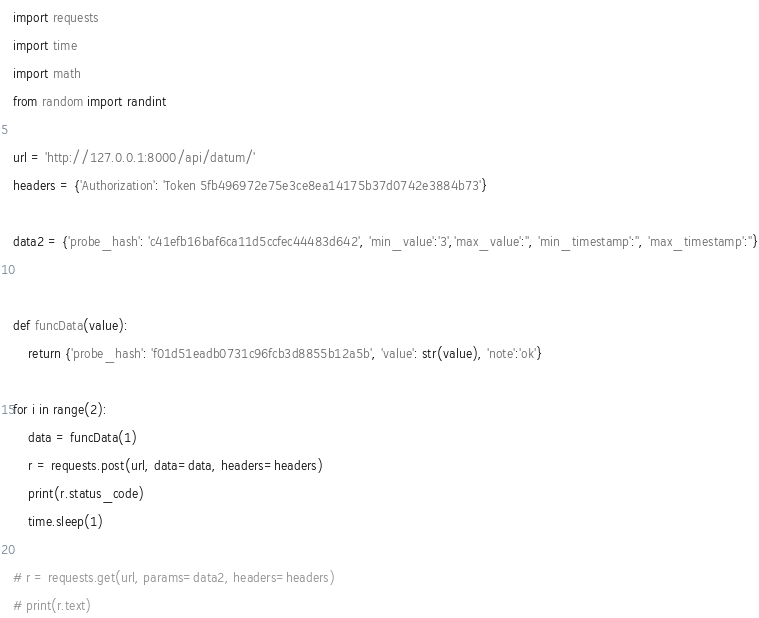<code> <loc_0><loc_0><loc_500><loc_500><_Python_>import requests
import time
import math
from random import randint

url = 'http://127.0.0.1:8000/api/datum/'
headers = {'Authorization': 'Token 5fb496972e75e3ce8ea14175b37d0742e3884b73'}

data2 = {'probe_hash': 'c41efb16baf6ca11d5ccfec44483d642', 'min_value':'3','max_value':'', 'min_timestamp':'', 'max_timestamp':''}


def funcData(value):
    return {'probe_hash': 'f01d51eadb0731c96fcb3d8855b12a5b', 'value': str(value), 'note':'ok'}

for i in range(2):
    data = funcData(1)
    r = requests.post(url, data=data, headers=headers)
    print(r.status_code)
    time.sleep(1)

# r = requests.get(url, params=data2, headers=headers)
# print(r.text)
</code> 